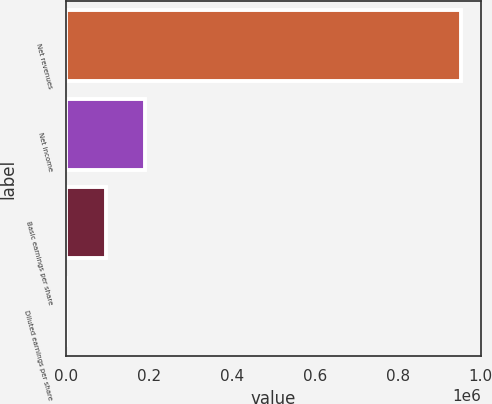Convert chart to OTSL. <chart><loc_0><loc_0><loc_500><loc_500><bar_chart><fcel>Net revenues<fcel>Net income<fcel>Basic earnings per share<fcel>Diluted earnings per share<nl><fcel>953255<fcel>190652<fcel>95326.1<fcel>0.68<nl></chart> 